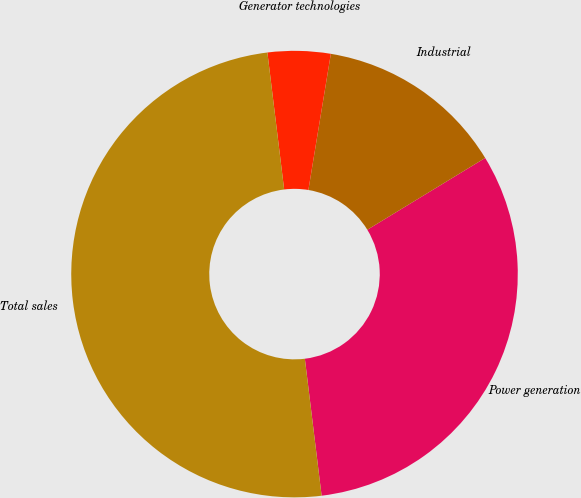<chart> <loc_0><loc_0><loc_500><loc_500><pie_chart><fcel>Power generation<fcel>Industrial<fcel>Generator technologies<fcel>Total sales<nl><fcel>31.77%<fcel>13.69%<fcel>4.54%<fcel>50.0%<nl></chart> 